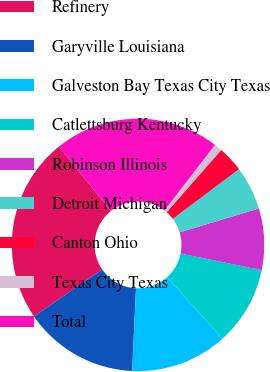Convert chart. <chart><loc_0><loc_0><loc_500><loc_500><pie_chart><fcel>Refinery<fcel>Garyville Louisiana<fcel>Galveston Bay Texas City Texas<fcel>Catlettsburg Kentucky<fcel>Robinson Illinois<fcel>Detroit Michigan<fcel>Canton Ohio<fcel>Texas City Texas<fcel>Total<nl><fcel>23.81%<fcel>14.69%<fcel>12.41%<fcel>10.13%<fcel>7.86%<fcel>5.58%<fcel>3.3%<fcel>1.02%<fcel>21.2%<nl></chart> 